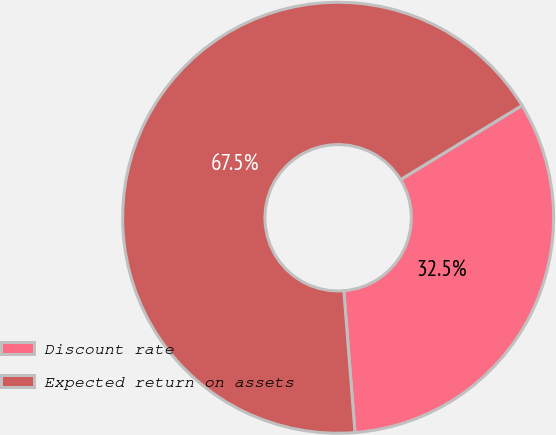Convert chart to OTSL. <chart><loc_0><loc_0><loc_500><loc_500><pie_chart><fcel>Discount rate<fcel>Expected return on assets<nl><fcel>32.48%<fcel>67.52%<nl></chart> 